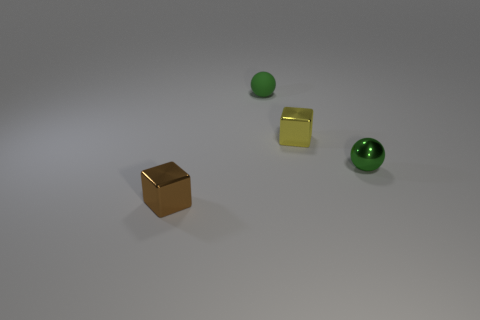What number of metal blocks are the same color as the rubber ball?
Your answer should be compact. 0. There is a matte thing that is the same shape as the green metallic object; what is its color?
Provide a short and direct response. Green. What is the small object that is in front of the small yellow shiny cube and behind the tiny brown cube made of?
Your response must be concise. Metal. Is the material of the small object that is in front of the small green metallic thing the same as the sphere in front of the tiny yellow object?
Provide a short and direct response. Yes. The green metal sphere is what size?
Offer a very short reply. Small. What size is the other shiny object that is the same shape as the tiny yellow thing?
Provide a succinct answer. Small. There is a small yellow thing; how many yellow objects are in front of it?
Your answer should be very brief. 0. The rubber sphere on the left side of the small shiny block right of the brown metallic object is what color?
Provide a succinct answer. Green. Is there anything else that is the same shape as the tiny yellow metallic object?
Ensure brevity in your answer.  Yes. Are there the same number of small things that are behind the tiny matte ball and green metallic things behind the yellow thing?
Provide a short and direct response. Yes. 